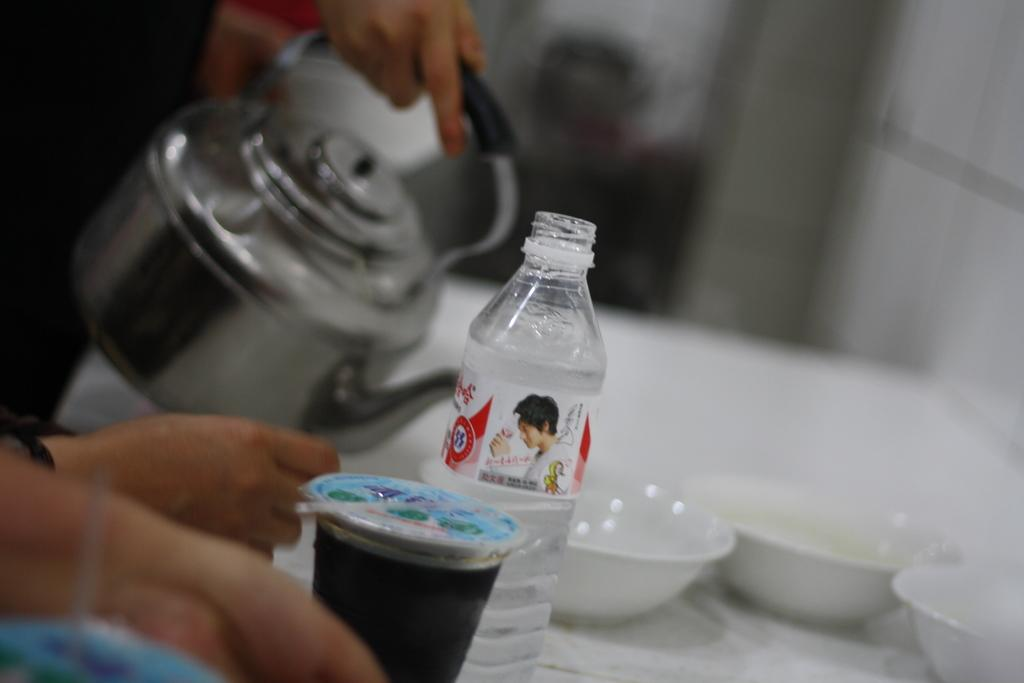What objects are on the table in the image? There are bowls, a bottle, and a cup on the table in the image. What is the person in the image holding? The person is holding a teapot. How many bowls are on the table? The number of bowls on the table is not specified, but there are at least two bowls visible. What type of leather is being used to make the tray in the image? There is no tray present in the image, so it is not possible to determine the type of leather being used. 